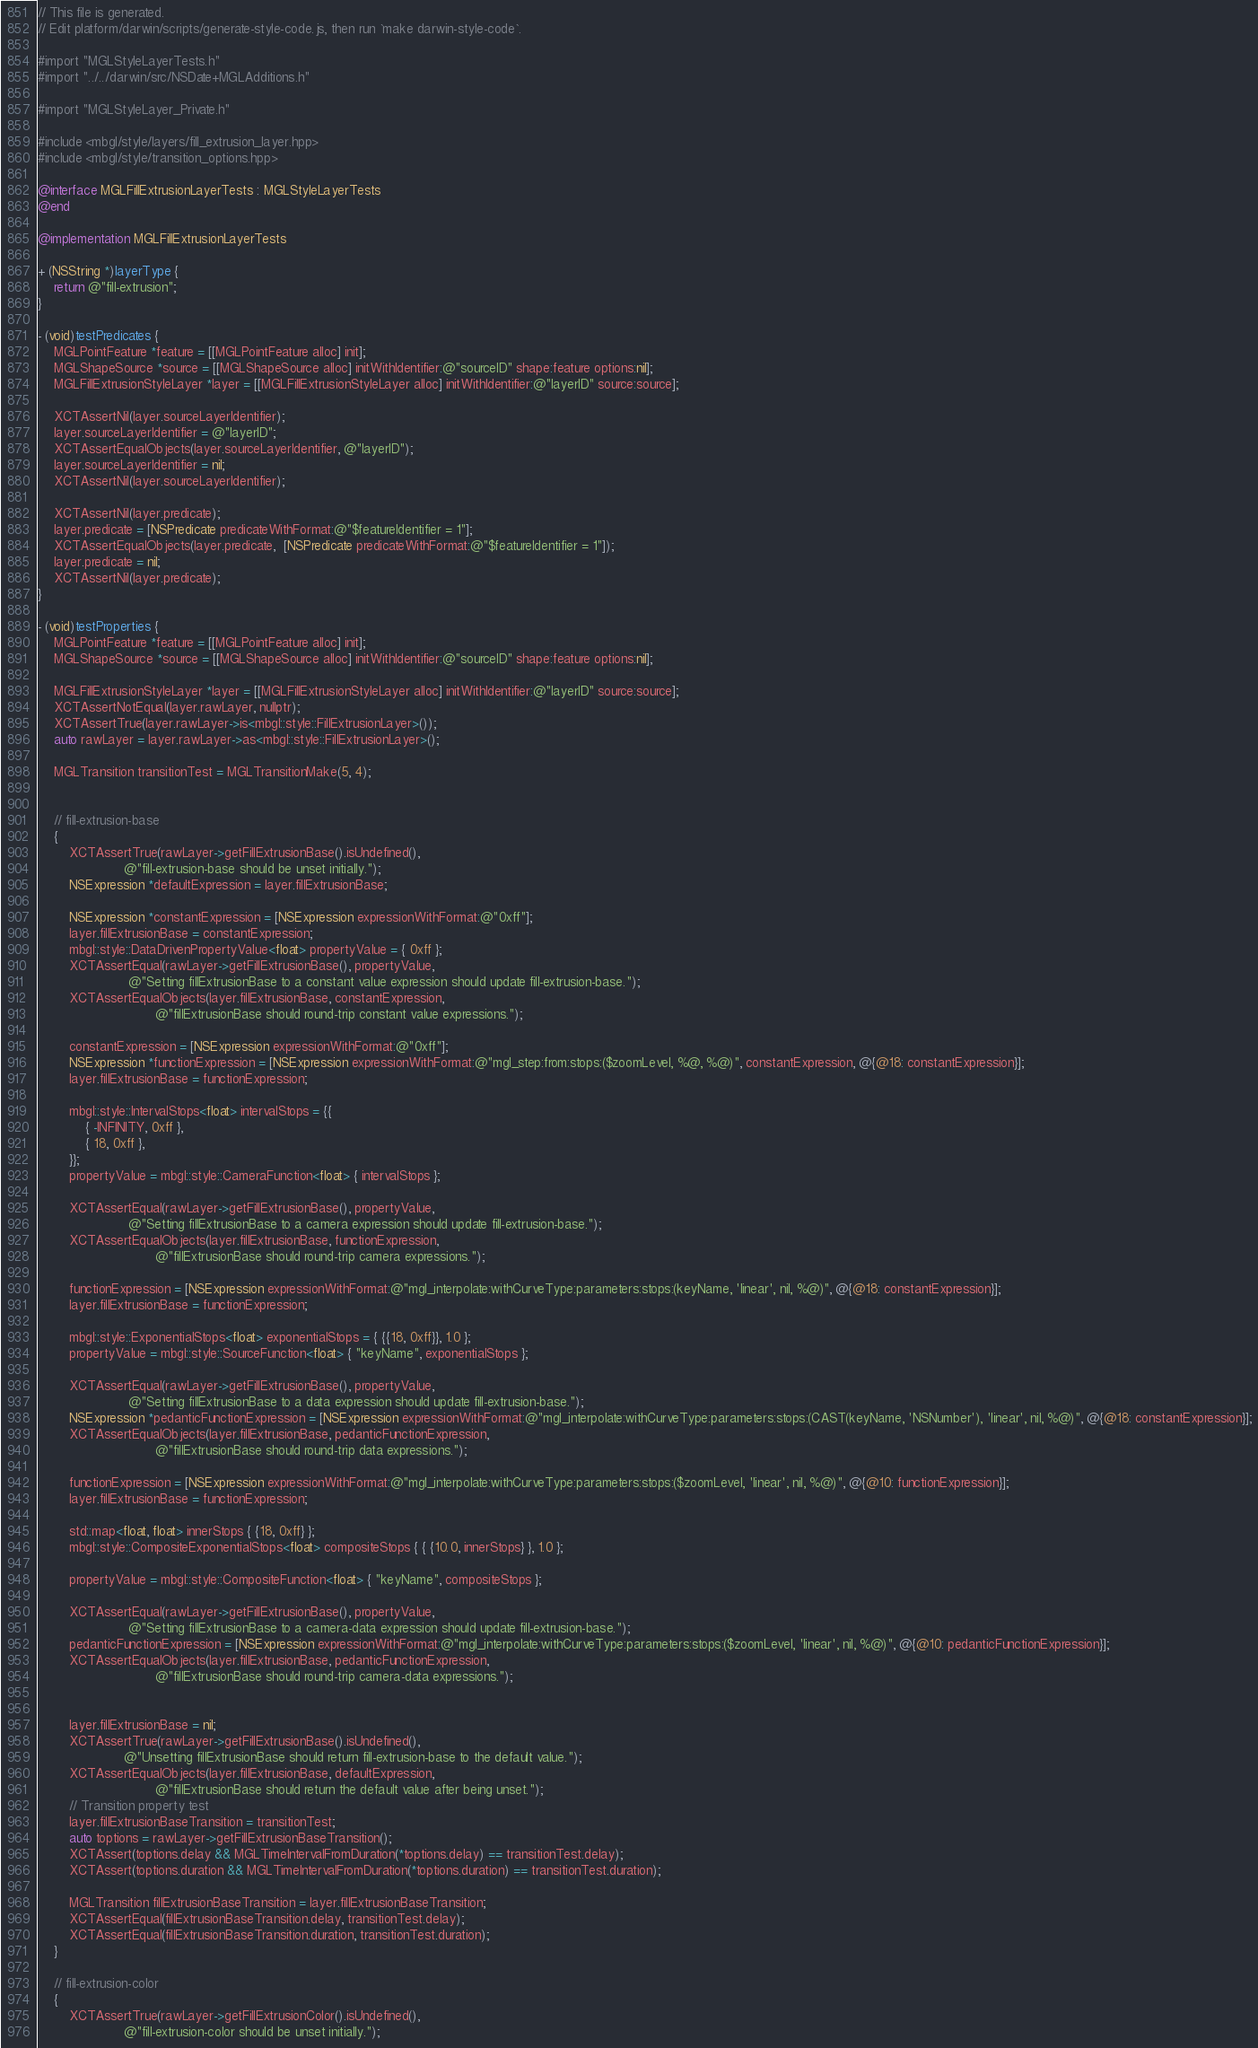<code> <loc_0><loc_0><loc_500><loc_500><_ObjectiveC_>// This file is generated.
// Edit platform/darwin/scripts/generate-style-code.js, then run `make darwin-style-code`.

#import "MGLStyleLayerTests.h"
#import "../../darwin/src/NSDate+MGLAdditions.h"

#import "MGLStyleLayer_Private.h"

#include <mbgl/style/layers/fill_extrusion_layer.hpp>
#include <mbgl/style/transition_options.hpp>

@interface MGLFillExtrusionLayerTests : MGLStyleLayerTests
@end

@implementation MGLFillExtrusionLayerTests

+ (NSString *)layerType {
    return @"fill-extrusion";
}

- (void)testPredicates {
    MGLPointFeature *feature = [[MGLPointFeature alloc] init];
    MGLShapeSource *source = [[MGLShapeSource alloc] initWithIdentifier:@"sourceID" shape:feature options:nil];
    MGLFillExtrusionStyleLayer *layer = [[MGLFillExtrusionStyleLayer alloc] initWithIdentifier:@"layerID" source:source];

    XCTAssertNil(layer.sourceLayerIdentifier);
    layer.sourceLayerIdentifier = @"layerID";
    XCTAssertEqualObjects(layer.sourceLayerIdentifier, @"layerID");
    layer.sourceLayerIdentifier = nil;
    XCTAssertNil(layer.sourceLayerIdentifier);

    XCTAssertNil(layer.predicate);
    layer.predicate = [NSPredicate predicateWithFormat:@"$featureIdentifier = 1"];
    XCTAssertEqualObjects(layer.predicate,  [NSPredicate predicateWithFormat:@"$featureIdentifier = 1"]);
    layer.predicate = nil;
    XCTAssertNil(layer.predicate);
}

- (void)testProperties {
    MGLPointFeature *feature = [[MGLPointFeature alloc] init];
    MGLShapeSource *source = [[MGLShapeSource alloc] initWithIdentifier:@"sourceID" shape:feature options:nil];

    MGLFillExtrusionStyleLayer *layer = [[MGLFillExtrusionStyleLayer alloc] initWithIdentifier:@"layerID" source:source];
    XCTAssertNotEqual(layer.rawLayer, nullptr);
    XCTAssertTrue(layer.rawLayer->is<mbgl::style::FillExtrusionLayer>());
    auto rawLayer = layer.rawLayer->as<mbgl::style::FillExtrusionLayer>();

    MGLTransition transitionTest = MGLTransitionMake(5, 4);


    // fill-extrusion-base
    {
        XCTAssertTrue(rawLayer->getFillExtrusionBase().isUndefined(),
                      @"fill-extrusion-base should be unset initially.");
        NSExpression *defaultExpression = layer.fillExtrusionBase;

        NSExpression *constantExpression = [NSExpression expressionWithFormat:@"0xff"];
        layer.fillExtrusionBase = constantExpression;
        mbgl::style::DataDrivenPropertyValue<float> propertyValue = { 0xff };
        XCTAssertEqual(rawLayer->getFillExtrusionBase(), propertyValue,
                       @"Setting fillExtrusionBase to a constant value expression should update fill-extrusion-base.");
        XCTAssertEqualObjects(layer.fillExtrusionBase, constantExpression,
                              @"fillExtrusionBase should round-trip constant value expressions.");

        constantExpression = [NSExpression expressionWithFormat:@"0xff"];
        NSExpression *functionExpression = [NSExpression expressionWithFormat:@"mgl_step:from:stops:($zoomLevel, %@, %@)", constantExpression, @{@18: constantExpression}];
        layer.fillExtrusionBase = functionExpression;

        mbgl::style::IntervalStops<float> intervalStops = {{
            { -INFINITY, 0xff },
            { 18, 0xff },
        }};
        propertyValue = mbgl::style::CameraFunction<float> { intervalStops };
        
        XCTAssertEqual(rawLayer->getFillExtrusionBase(), propertyValue,
                       @"Setting fillExtrusionBase to a camera expression should update fill-extrusion-base.");
        XCTAssertEqualObjects(layer.fillExtrusionBase, functionExpression,
                              @"fillExtrusionBase should round-trip camera expressions.");

        functionExpression = [NSExpression expressionWithFormat:@"mgl_interpolate:withCurveType:parameters:stops:(keyName, 'linear', nil, %@)", @{@18: constantExpression}];
        layer.fillExtrusionBase = functionExpression;

        mbgl::style::ExponentialStops<float> exponentialStops = { {{18, 0xff}}, 1.0 };
        propertyValue = mbgl::style::SourceFunction<float> { "keyName", exponentialStops };

        XCTAssertEqual(rawLayer->getFillExtrusionBase(), propertyValue,
                       @"Setting fillExtrusionBase to a data expression should update fill-extrusion-base.");
        NSExpression *pedanticFunctionExpression = [NSExpression expressionWithFormat:@"mgl_interpolate:withCurveType:parameters:stops:(CAST(keyName, 'NSNumber'), 'linear', nil, %@)", @{@18: constantExpression}];
        XCTAssertEqualObjects(layer.fillExtrusionBase, pedanticFunctionExpression,
                              @"fillExtrusionBase should round-trip data expressions.");

        functionExpression = [NSExpression expressionWithFormat:@"mgl_interpolate:withCurveType:parameters:stops:($zoomLevel, 'linear', nil, %@)", @{@10: functionExpression}];
        layer.fillExtrusionBase = functionExpression;

        std::map<float, float> innerStops { {18, 0xff} };
        mbgl::style::CompositeExponentialStops<float> compositeStops { { {10.0, innerStops} }, 1.0 };

        propertyValue = mbgl::style::CompositeFunction<float> { "keyName", compositeStops };

        XCTAssertEqual(rawLayer->getFillExtrusionBase(), propertyValue,
                       @"Setting fillExtrusionBase to a camera-data expression should update fill-extrusion-base.");
        pedanticFunctionExpression = [NSExpression expressionWithFormat:@"mgl_interpolate:withCurveType:parameters:stops:($zoomLevel, 'linear', nil, %@)", @{@10: pedanticFunctionExpression}];
        XCTAssertEqualObjects(layer.fillExtrusionBase, pedanticFunctionExpression,
                              @"fillExtrusionBase should round-trip camera-data expressions.");
                              

        layer.fillExtrusionBase = nil;
        XCTAssertTrue(rawLayer->getFillExtrusionBase().isUndefined(),
                      @"Unsetting fillExtrusionBase should return fill-extrusion-base to the default value.");
        XCTAssertEqualObjects(layer.fillExtrusionBase, defaultExpression,
                              @"fillExtrusionBase should return the default value after being unset.");
        // Transition property test
        layer.fillExtrusionBaseTransition = transitionTest;
        auto toptions = rawLayer->getFillExtrusionBaseTransition();
        XCTAssert(toptions.delay && MGLTimeIntervalFromDuration(*toptions.delay) == transitionTest.delay);
        XCTAssert(toptions.duration && MGLTimeIntervalFromDuration(*toptions.duration) == transitionTest.duration);

        MGLTransition fillExtrusionBaseTransition = layer.fillExtrusionBaseTransition;
        XCTAssertEqual(fillExtrusionBaseTransition.delay, transitionTest.delay);
        XCTAssertEqual(fillExtrusionBaseTransition.duration, transitionTest.duration);
    }

    // fill-extrusion-color
    {
        XCTAssertTrue(rawLayer->getFillExtrusionColor().isUndefined(),
                      @"fill-extrusion-color should be unset initially.");</code> 